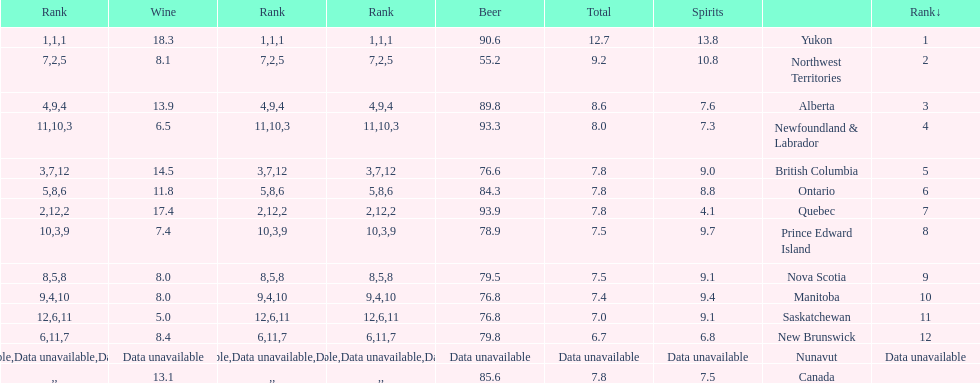Tell me province that drank more than 15 liters of wine. Yukon, Quebec. 